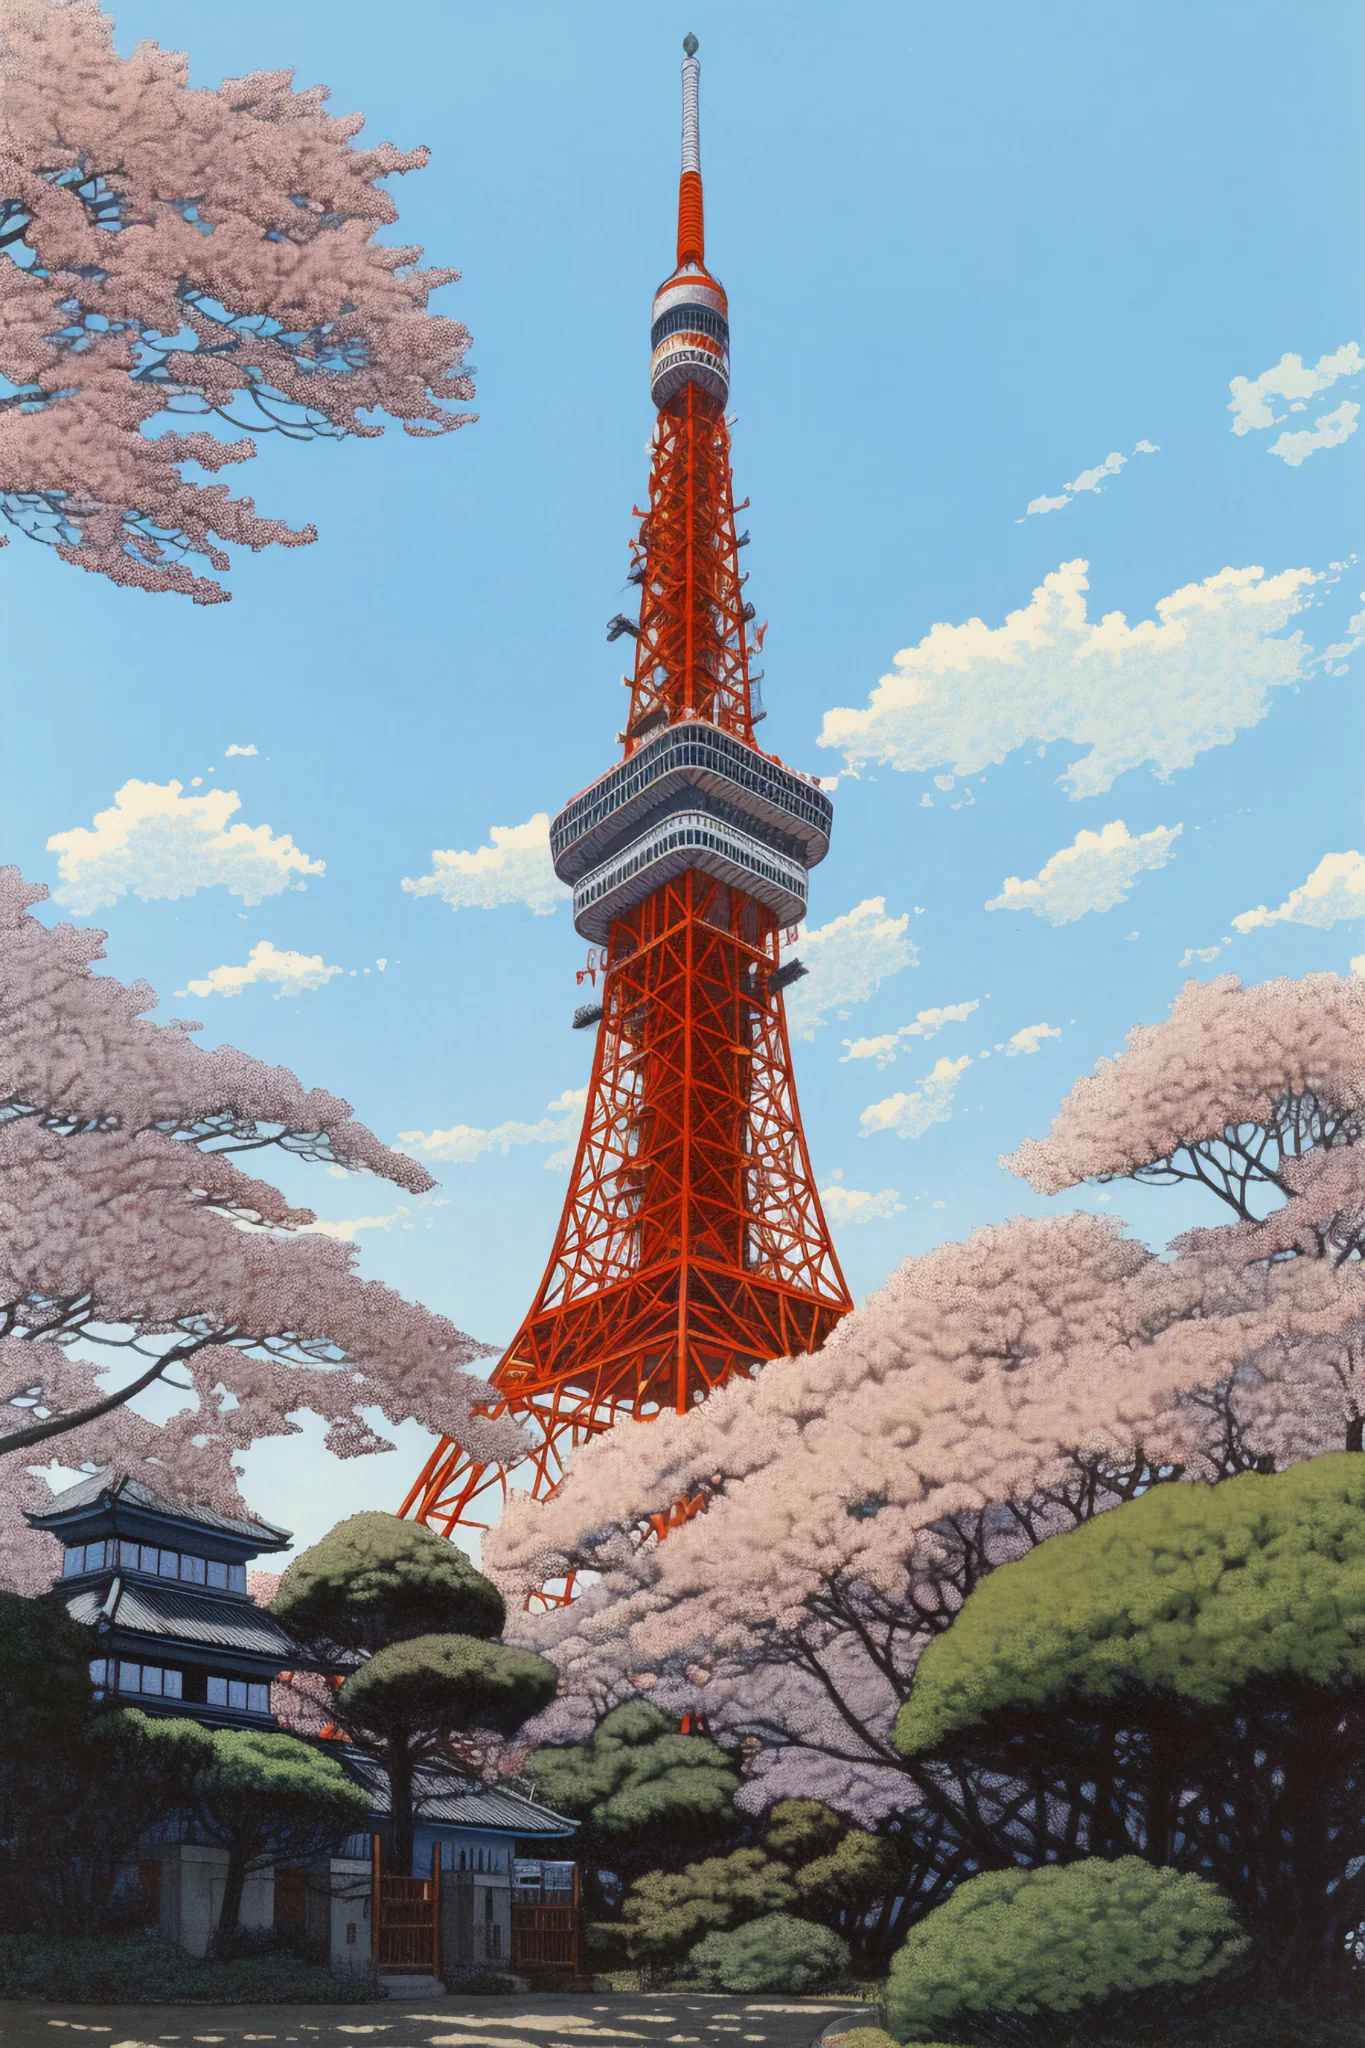What are the key elements in this picture? The image highlights Tokyo Tower, a significant landmark in Japan, distinguished by its striking orange hue. The tower soars against a pristine blue sky, creating a sense of its impressive height. At its base, a profusion of pink cherry blossom trees can be seen in full bloom, complemented by green shrubs that enhance the natural beauty around the structure. This beautiful contrast between the urban and natural elements makes the scene especially captivating. 